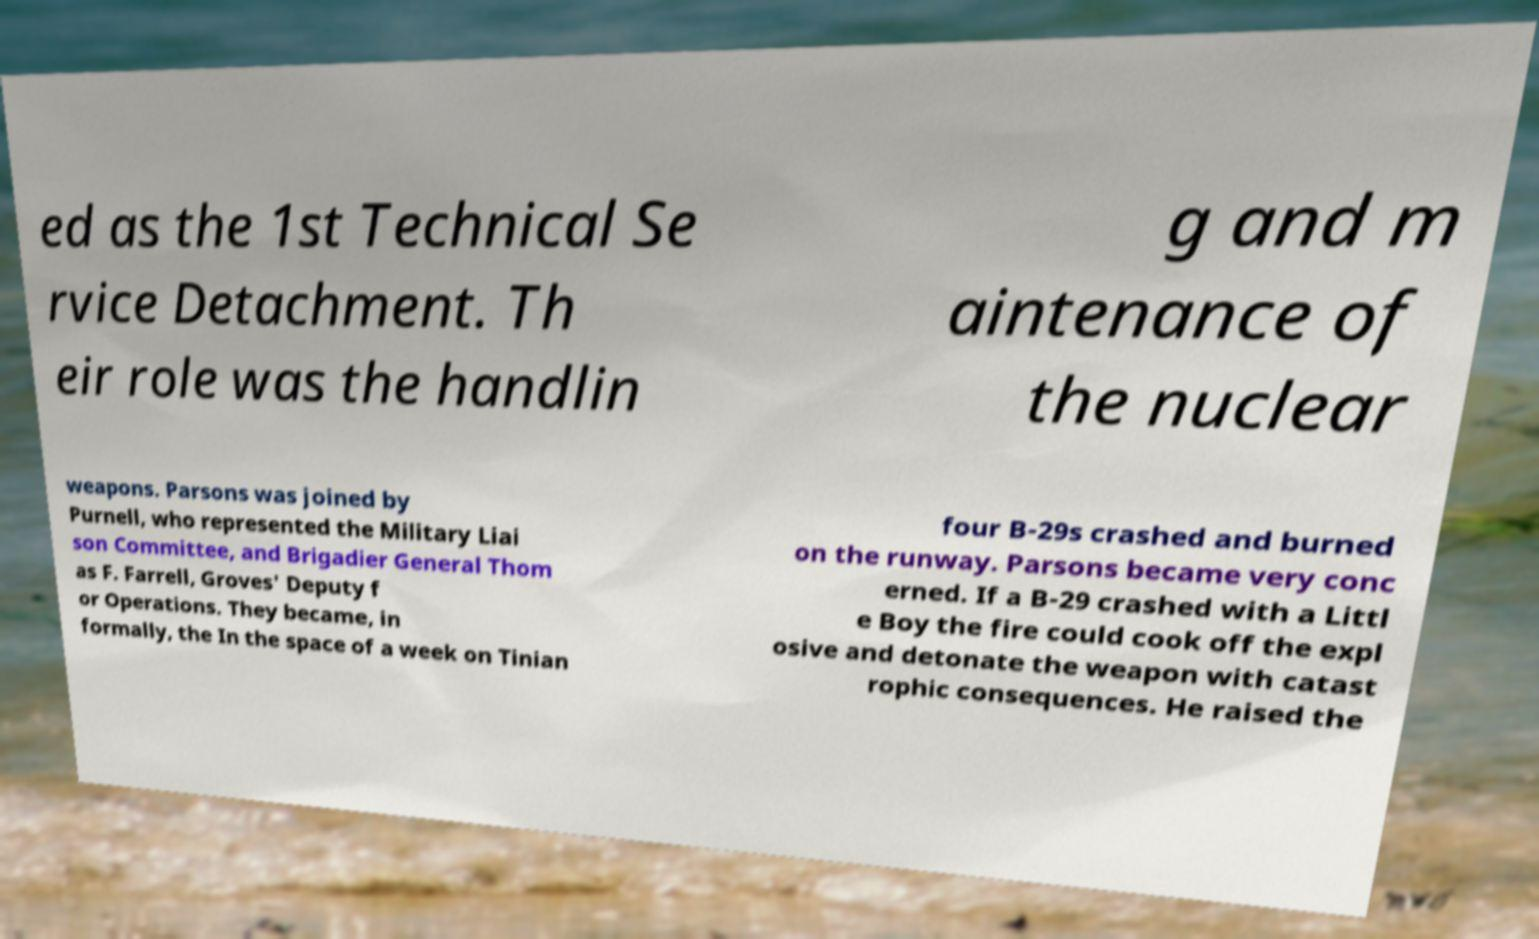Can you read and provide the text displayed in the image?This photo seems to have some interesting text. Can you extract and type it out for me? ed as the 1st Technical Se rvice Detachment. Th eir role was the handlin g and m aintenance of the nuclear weapons. Parsons was joined by Purnell, who represented the Military Liai son Committee, and Brigadier General Thom as F. Farrell, Groves' Deputy f or Operations. They became, in formally, the In the space of a week on Tinian four B-29s crashed and burned on the runway. Parsons became very conc erned. If a B-29 crashed with a Littl e Boy the fire could cook off the expl osive and detonate the weapon with catast rophic consequences. He raised the 